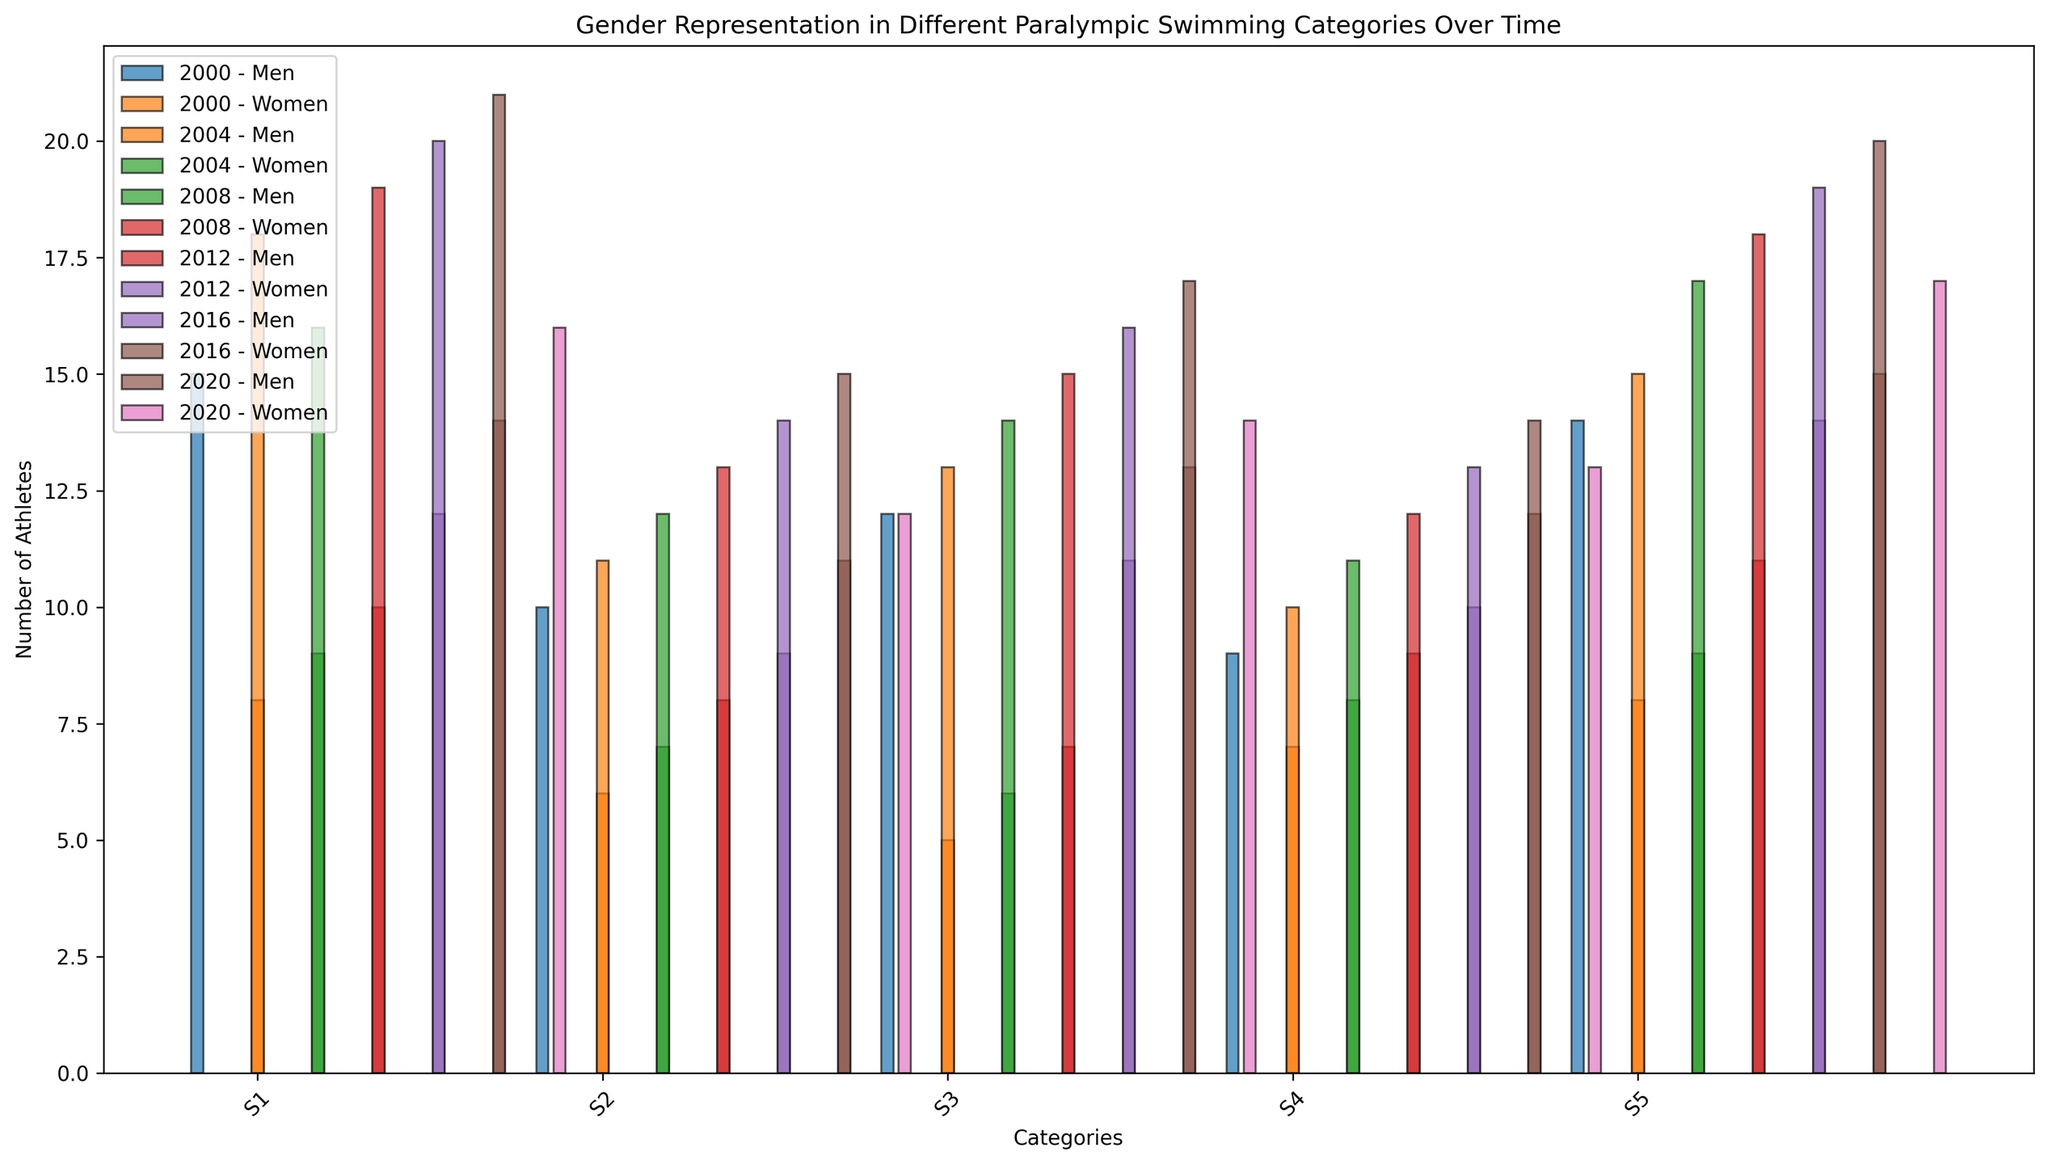Which year had the highest number of male athletes in the S1 category? To find the year with the highest number of male athletes in the S1 category, check the bars representing each year in the S1 category and compare their heights. The 2020 bar is the tallest, indicating 21 athletes.
Answer: 2020 How did the number of female athletes in the S5 category change from 2000 to 2020? Compare the height of the bars representing female athletes in the S5 category for the years 2000 and 2020. In 2000, there were 8 female athletes, and in 2020, there were 17. The change can be calculated as 17 - 8.
Answer: Increased by 9 Which category had the lowest number of male athletes in the year 2004? Look for the shortest bars among male athletes in different categories for the year 2004. The shortest bar corresponds to the S4 category, with 10 athletes.
Answer: S4 In 2012, is there a category where the number of female athletes was greater than the number of male athletes? Compare the bar heights of male and female athletes for each category in 2012. In all categories (S1 to S5), the bars representing male athletes are taller than or equal to those representing female athletes.
Answer: No What is the total number of athletes in the S3 category for the year 2016? Add the heights of the bars representing male and female athletes in the S3 category for the year 2016. Male athletes are 16 and female athletes are 13, making the total 16 + 13.
Answer: 29 Which year shows the smallest gender gap in the S2 category? Calculate the difference between the heights of male and female athlete bars in the S2 category for each year. The smallest difference is seen in the year 2016, with a gap of 3 (14 male - 11 female).
Answer: 2016 How did the number of male athletes in the S4 category change from 2008 to 2016? Compare the heights of the bars representing male athletes in the S4 category for the years 2008 and 2016. In 2008, there were 11 male athletes, and in 2016, there were 13. The change can be calculated as 13 - 11.
Answer: Increased by 2 What is the average number of female athletes in the S1 category over all years? Sum the number of female athletes in the S1 category across all recorded years (8 + 9 + 10 + 12 + 14 + 16) and divide by the number of years (6). This gives (8 + 9 + 10 + 12 + 14 + 16) / 6 = 69 / 6.
Answer: 11.5 In which year did the S5 category have the most balanced gender representation? Find the year where the difference between male and female athletes in the S5 category is the smallest. In 2020, the difference is only 3 (20 male - 17 female).
Answer: 2020 